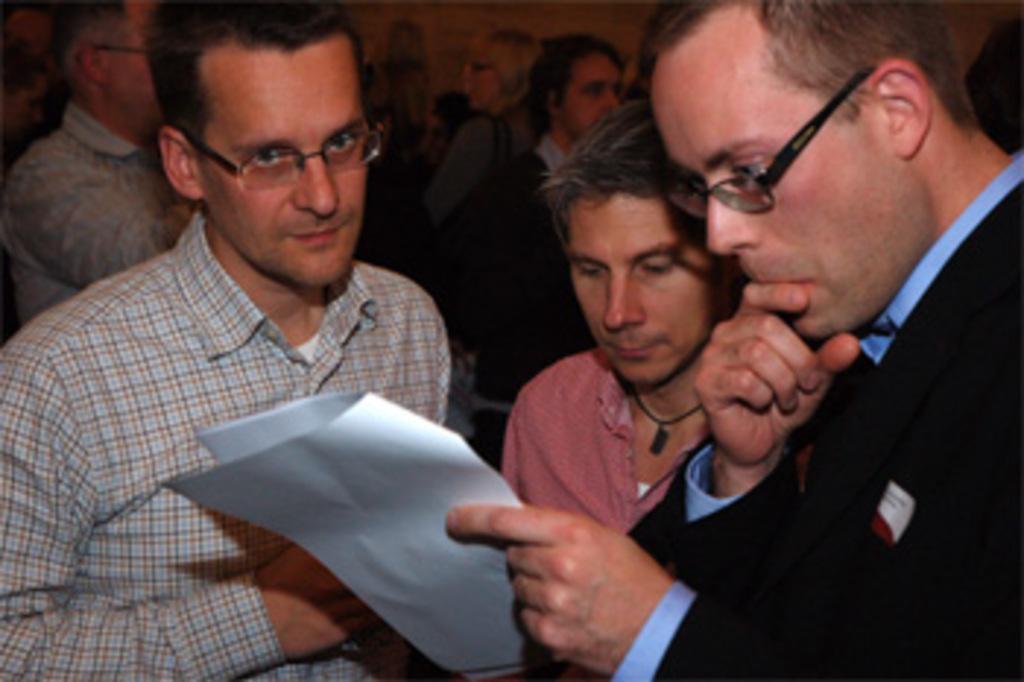Can you describe this image briefly? In this image we can see a group of people standing. One person is holding a paper in his hands. 